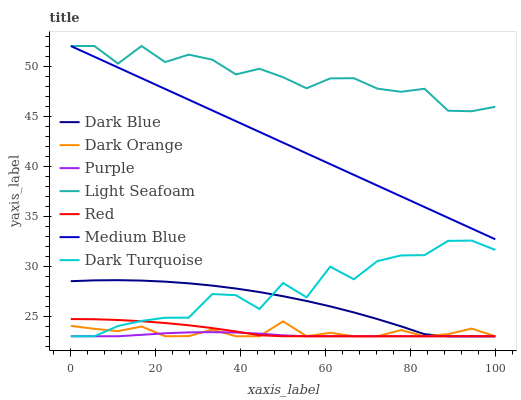Does Purple have the minimum area under the curve?
Answer yes or no. Yes. Does Light Seafoam have the maximum area under the curve?
Answer yes or no. Yes. Does Dark Turquoise have the minimum area under the curve?
Answer yes or no. No. Does Dark Turquoise have the maximum area under the curve?
Answer yes or no. No. Is Medium Blue the smoothest?
Answer yes or no. Yes. Is Dark Turquoise the roughest?
Answer yes or no. Yes. Is Purple the smoothest?
Answer yes or no. No. Is Purple the roughest?
Answer yes or no. No. Does Dark Orange have the lowest value?
Answer yes or no. Yes. Does Medium Blue have the lowest value?
Answer yes or no. No. Does Light Seafoam have the highest value?
Answer yes or no. Yes. Does Dark Turquoise have the highest value?
Answer yes or no. No. Is Dark Orange less than Light Seafoam?
Answer yes or no. Yes. Is Medium Blue greater than Purple?
Answer yes or no. Yes. Does Purple intersect Dark Orange?
Answer yes or no. Yes. Is Purple less than Dark Orange?
Answer yes or no. No. Is Purple greater than Dark Orange?
Answer yes or no. No. Does Dark Orange intersect Light Seafoam?
Answer yes or no. No. 